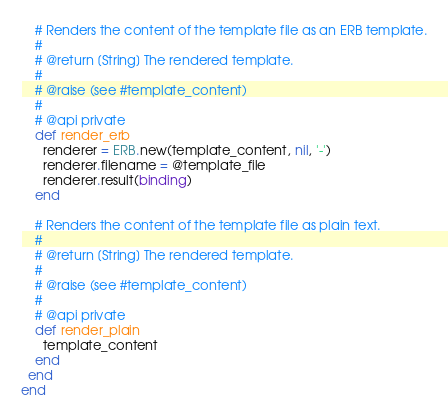Convert code to text. <code><loc_0><loc_0><loc_500><loc_500><_Ruby_>
    # Renders the content of the template file as an ERB template.
    #
    # @return [String] The rendered template.
    #
    # @raise (see #template_content)
    #
    # @api private
    def render_erb
      renderer = ERB.new(template_content, nil, '-')
      renderer.filename = @template_file
      renderer.result(binding)
    end

    # Renders the content of the template file as plain text.
    #
    # @return [String] The rendered template.
    #
    # @raise (see #template_content)
    #
    # @api private
    def render_plain
      template_content
    end
  end
end
</code> 